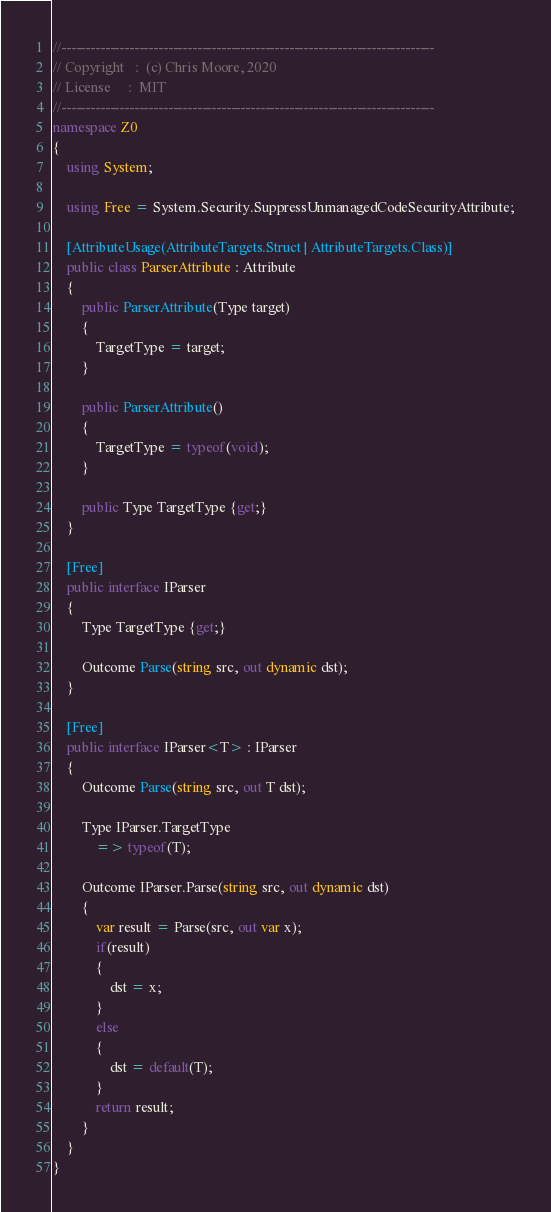Convert code to text. <code><loc_0><loc_0><loc_500><loc_500><_C#_>//-----------------------------------------------------------------------------
// Copyright   :  (c) Chris Moore, 2020
// License     :  MIT
//-----------------------------------------------------------------------------
namespace Z0
{
    using System;

    using Free = System.Security.SuppressUnmanagedCodeSecurityAttribute;

    [AttributeUsage(AttributeTargets.Struct | AttributeTargets.Class)]
    public class ParserAttribute : Attribute
    {
        public ParserAttribute(Type target)
        {
            TargetType = target;
        }

        public ParserAttribute()
        {
            TargetType = typeof(void);
        }

        public Type TargetType {get;}
    }

    [Free]
    public interface IParser
    {
        Type TargetType {get;}

        Outcome Parse(string src, out dynamic dst);
    }

    [Free]
    public interface IParser<T> : IParser
    {
        Outcome Parse(string src, out T dst);

        Type IParser.TargetType
            => typeof(T);

        Outcome IParser.Parse(string src, out dynamic dst)
        {
            var result = Parse(src, out var x);
            if(result)
            {
                dst = x;
            }
            else
            {
                dst = default(T);
            }
            return result;
        }
    }
}</code> 